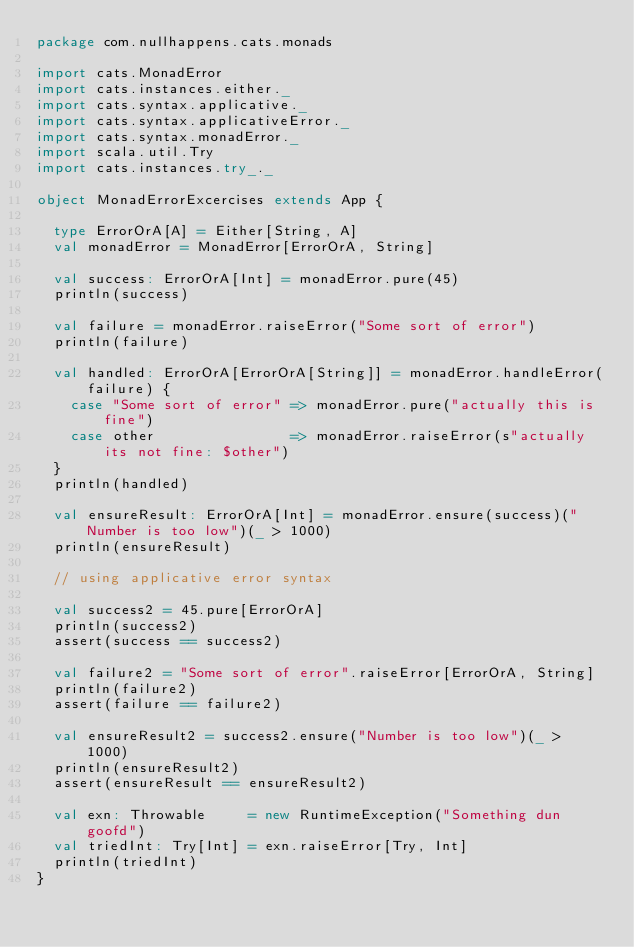<code> <loc_0><loc_0><loc_500><loc_500><_Scala_>package com.nullhappens.cats.monads

import cats.MonadError
import cats.instances.either._
import cats.syntax.applicative._
import cats.syntax.applicativeError._
import cats.syntax.monadError._
import scala.util.Try
import cats.instances.try_._

object MonadErrorExcercises extends App {

  type ErrorOrA[A] = Either[String, A]
  val monadError = MonadError[ErrorOrA, String]

  val success: ErrorOrA[Int] = monadError.pure(45)
  println(success)

  val failure = monadError.raiseError("Some sort of error")
  println(failure)

  val handled: ErrorOrA[ErrorOrA[String]] = monadError.handleError(failure) {
    case "Some sort of error" => monadError.pure("actually this is fine")
    case other                => monadError.raiseError(s"actually its not fine: $other")
  }
  println(handled)

  val ensureResult: ErrorOrA[Int] = monadError.ensure(success)("Number is too low")(_ > 1000)
  println(ensureResult)

  // using applicative error syntax

  val success2 = 45.pure[ErrorOrA]
  println(success2)
  assert(success == success2)

  val failure2 = "Some sort of error".raiseError[ErrorOrA, String]
  println(failure2)
  assert(failure == failure2)

  val ensureResult2 = success2.ensure("Number is too low")(_ > 1000)
  println(ensureResult2)
  assert(ensureResult == ensureResult2)

  val exn: Throwable     = new RuntimeException("Something dun goofd")
  val triedInt: Try[Int] = exn.raiseError[Try, Int]
  println(triedInt)
}
</code> 